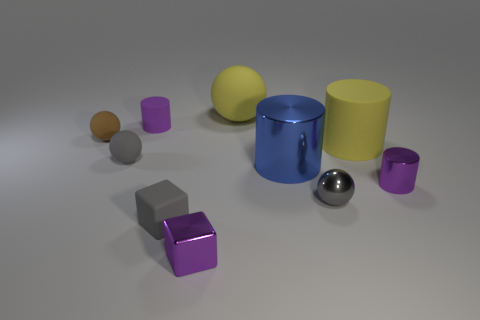Subtract all cubes. How many objects are left? 8 Add 3 small purple cylinders. How many small purple cylinders exist? 5 Subtract 0 green balls. How many objects are left? 10 Subtract all shiny cubes. Subtract all purple metallic objects. How many objects are left? 7 Add 3 purple shiny objects. How many purple shiny objects are left? 5 